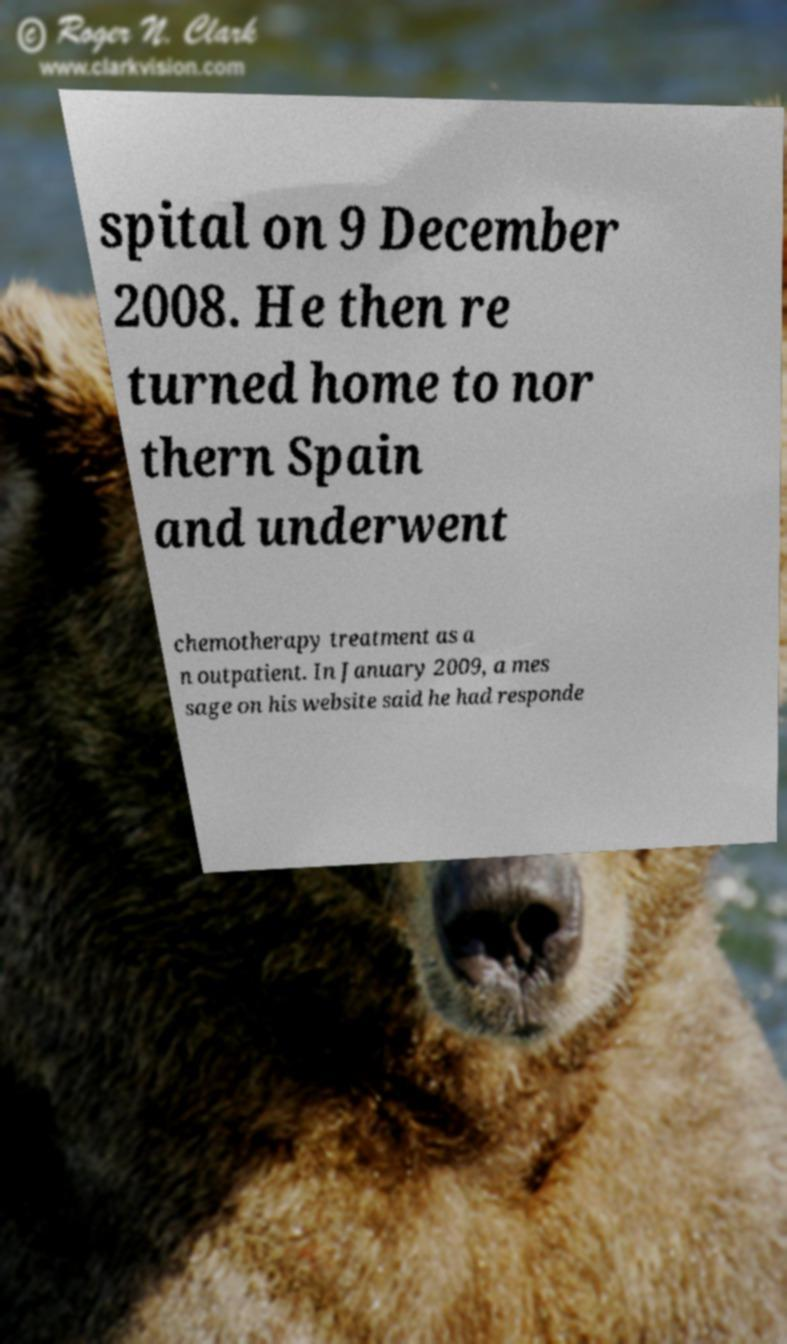Please read and relay the text visible in this image. What does it say? spital on 9 December 2008. He then re turned home to nor thern Spain and underwent chemotherapy treatment as a n outpatient. In January 2009, a mes sage on his website said he had responde 